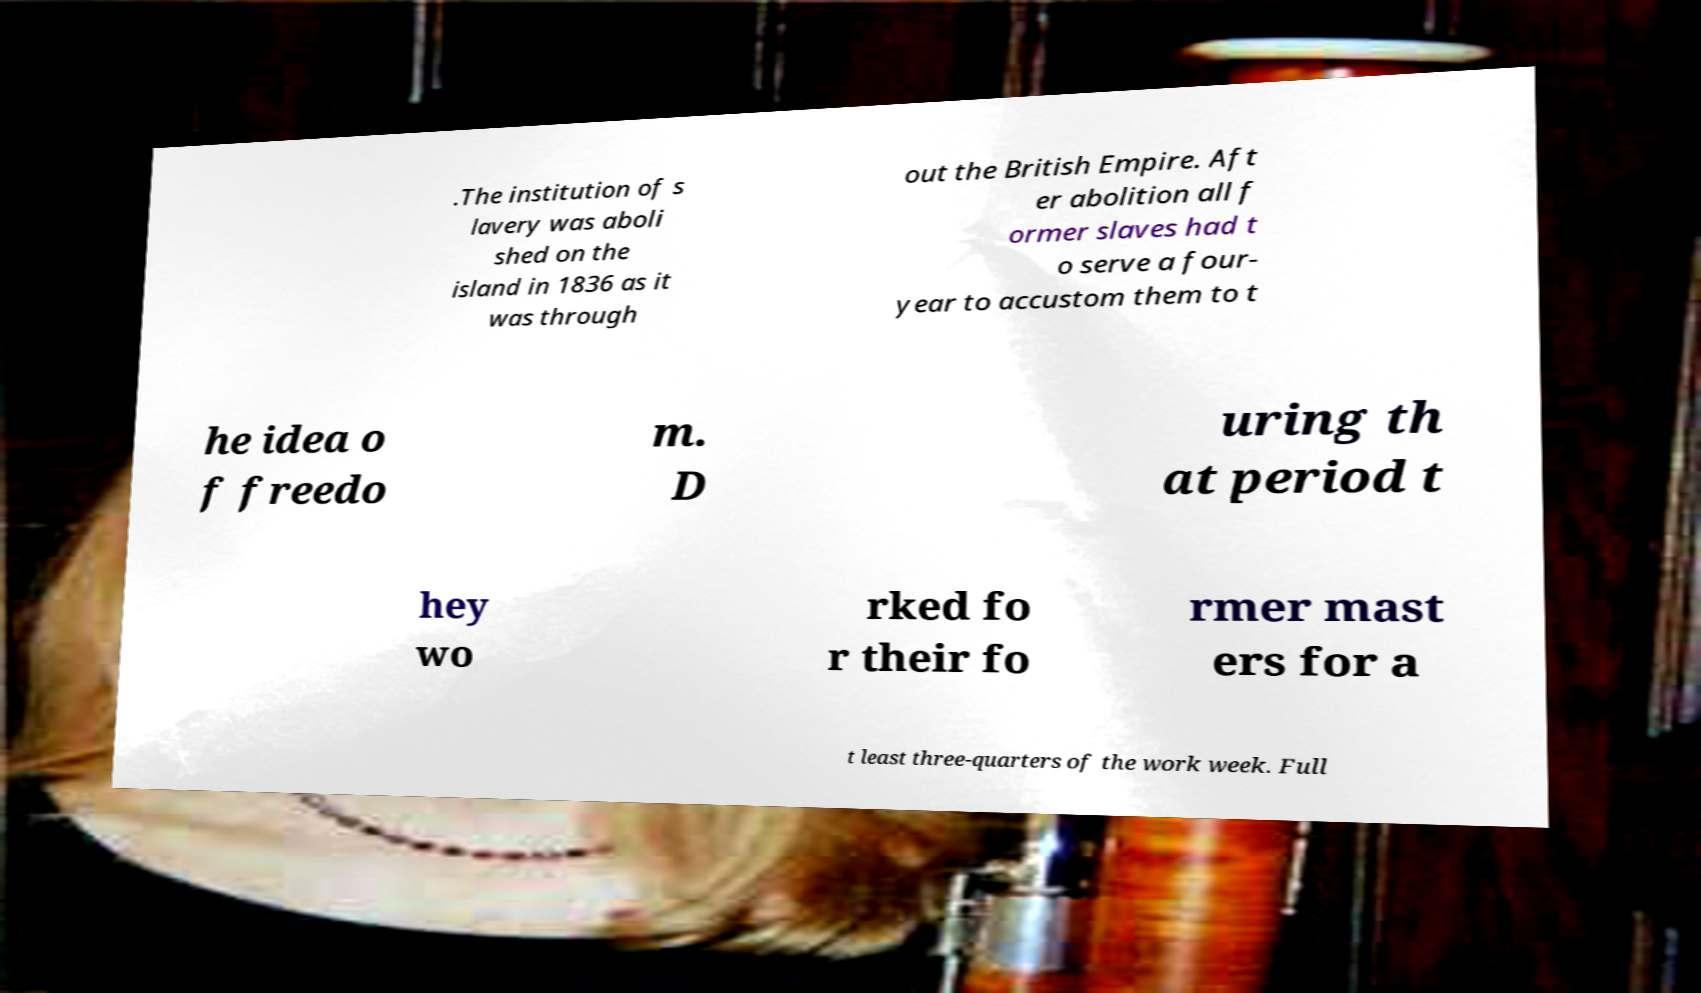I need the written content from this picture converted into text. Can you do that? .The institution of s lavery was aboli shed on the island in 1836 as it was through out the British Empire. Aft er abolition all f ormer slaves had t o serve a four- year to accustom them to t he idea o f freedo m. D uring th at period t hey wo rked fo r their fo rmer mast ers for a t least three-quarters of the work week. Full 